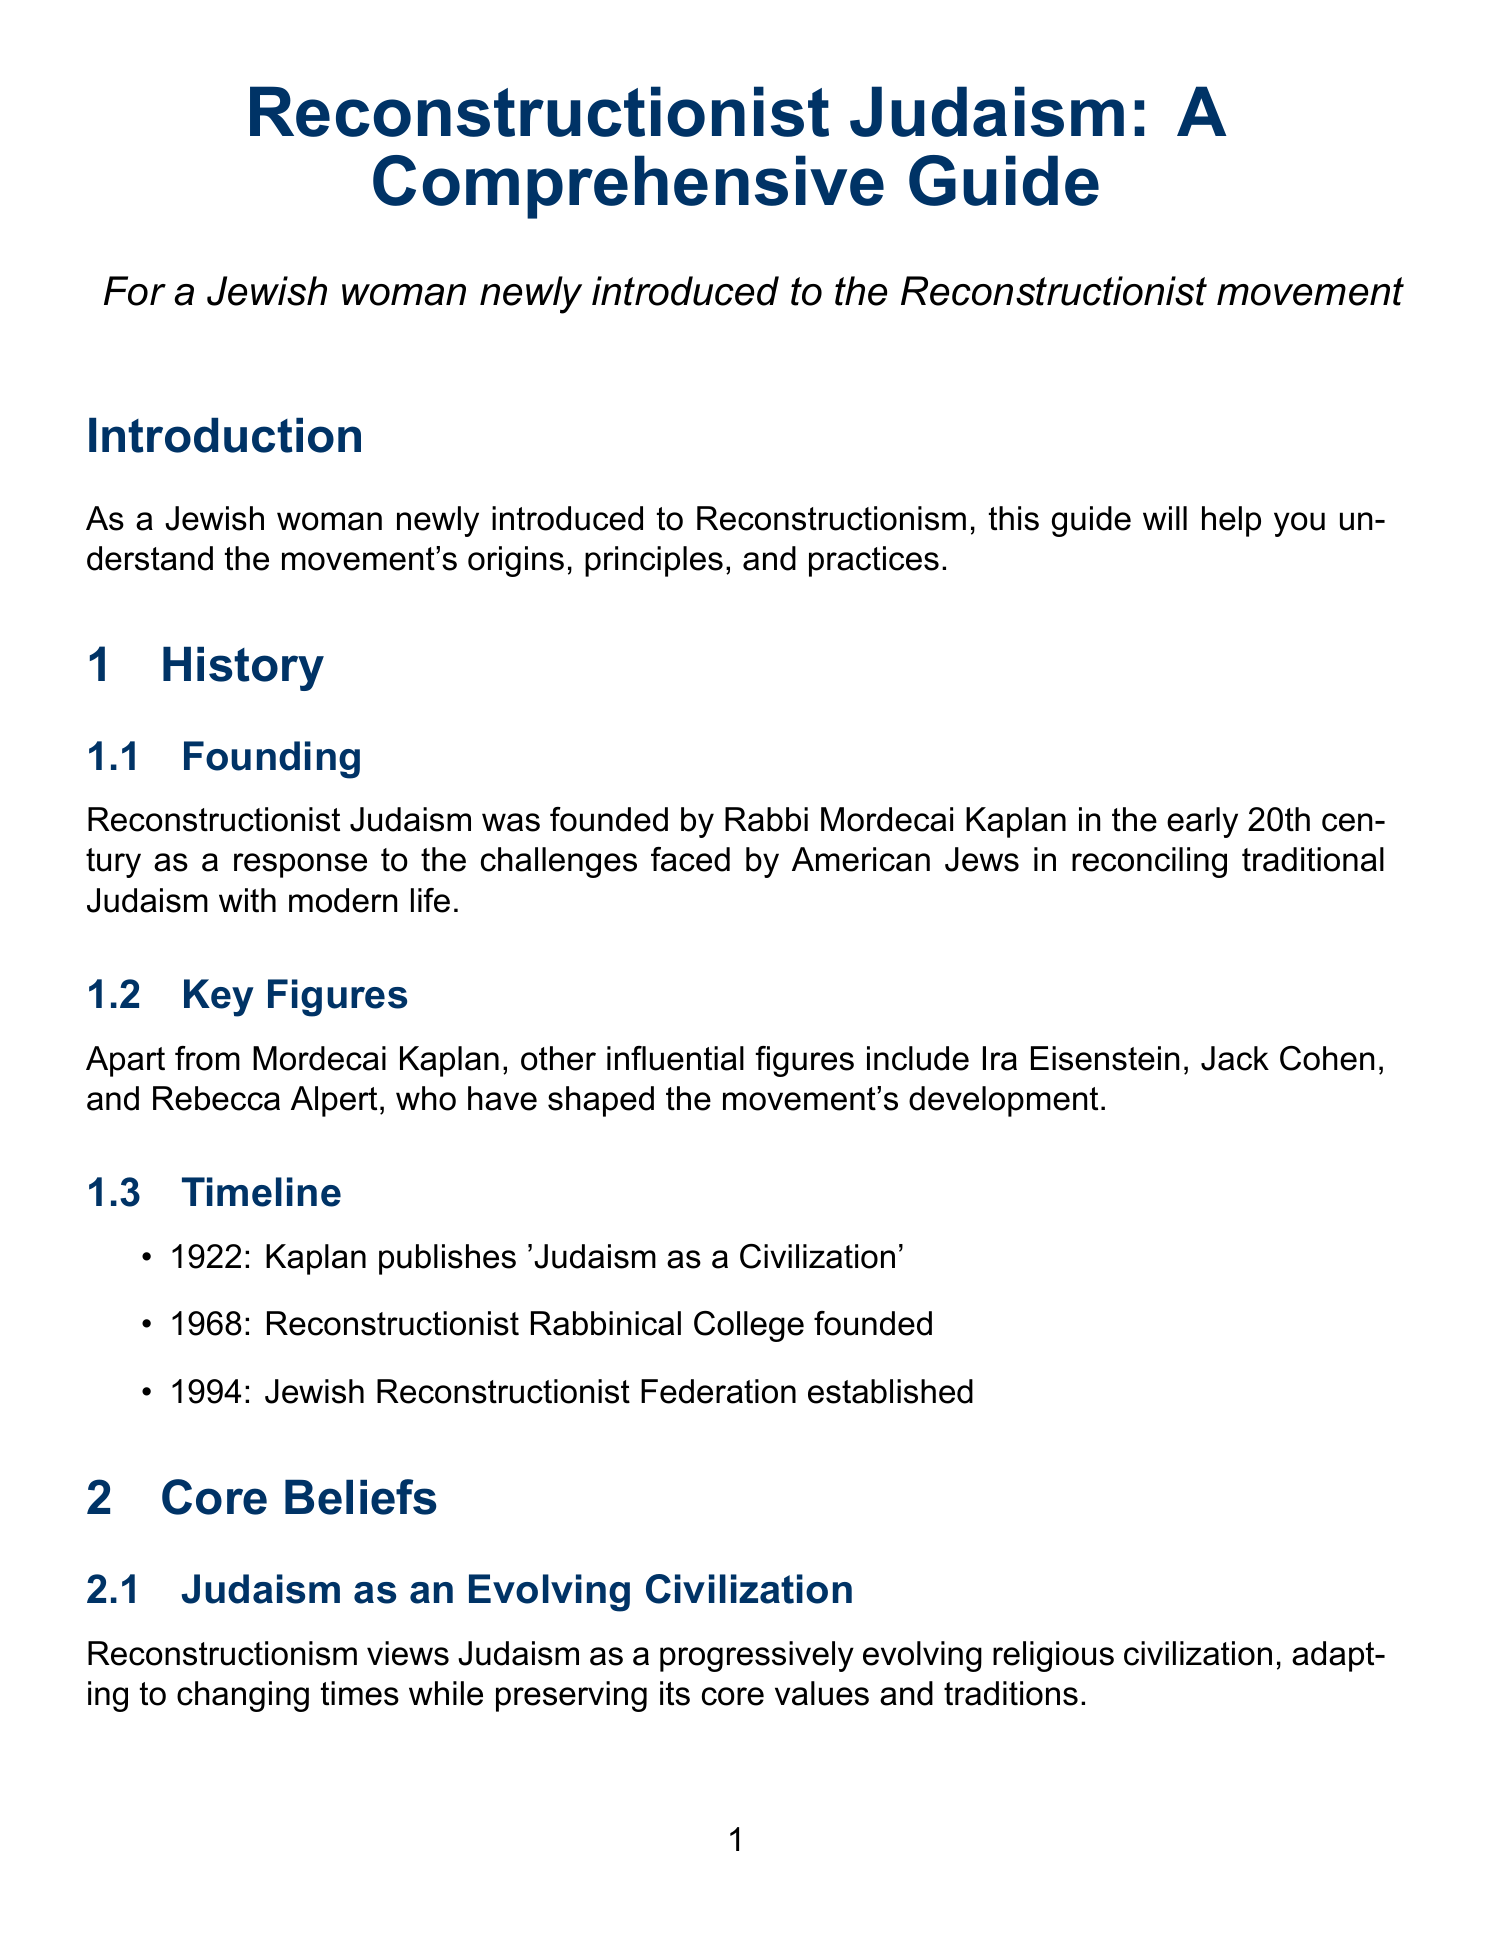What is the title of the guide? The title is explicitly stated at the beginning of the document.
Answer: Reconstructionist Judaism: A Comprehensive Guide Who founded Reconstructionist Judaism? The guide provides the name of the individual who established the movement in the founding section.
Answer: Rabbi Mordecai Kaplan What year was the Reconstructionist Rabbinical College founded? The timeline in the document specifically mentions this date.
Answer: 1968 What is the primary focus of Tikkun olam in Reconstructionist practice? The content in the modern practices section highlights the importance of this concept.
Answer: Social and environmental activism How does Reconstructionism reinterpret the concept of 'chosen people'? The explanation in the core beliefs section clarifies this reinterpretation.
Answer: Unique responsibility to live ethically and promote justice What does the organization "Reconstructing Judaism" represent? The document describes this organization in the organizational structure section.
Answer: The central organization of the movement Which prayer book is mentioned in the context of liturgy? The modern practices section includes the name of a specific prayer book.
Answer: Kol Haneshamah How many Reconstructionist congregations exist worldwide? The document provides a quantitative detail regarding the number of these congregations.
Answer: Over 100 